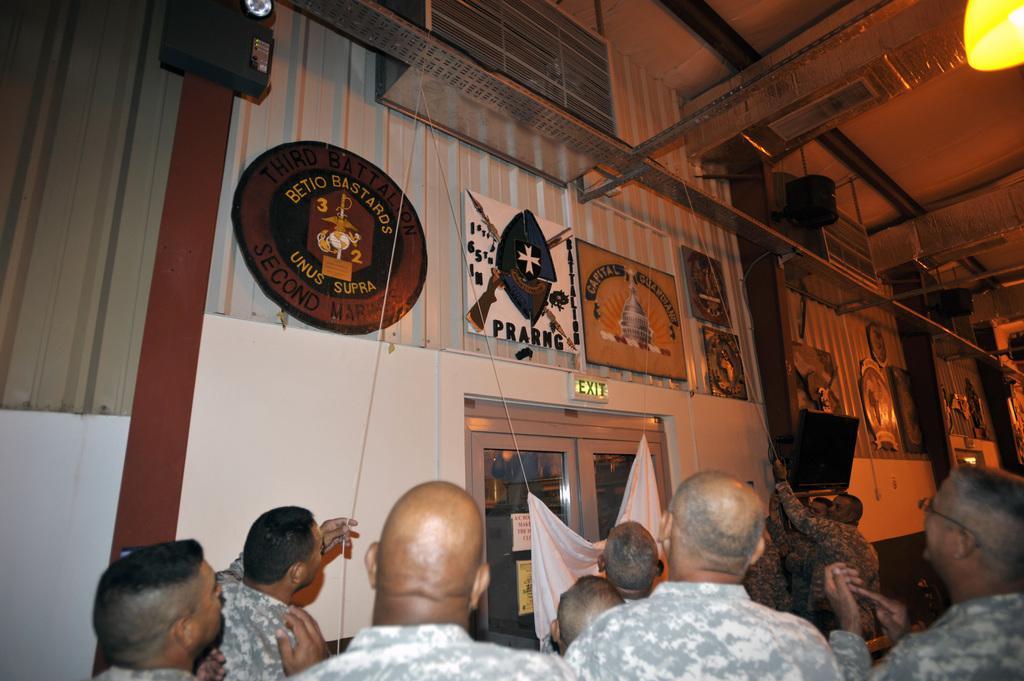Can you describe this image briefly? At the bottom we can see few persons and among them few persons are holding rope in their hands. There are frames,badges,screen and speakers on the wall and there is a cloth and posters on the door. On the right at the top we can see a light. 